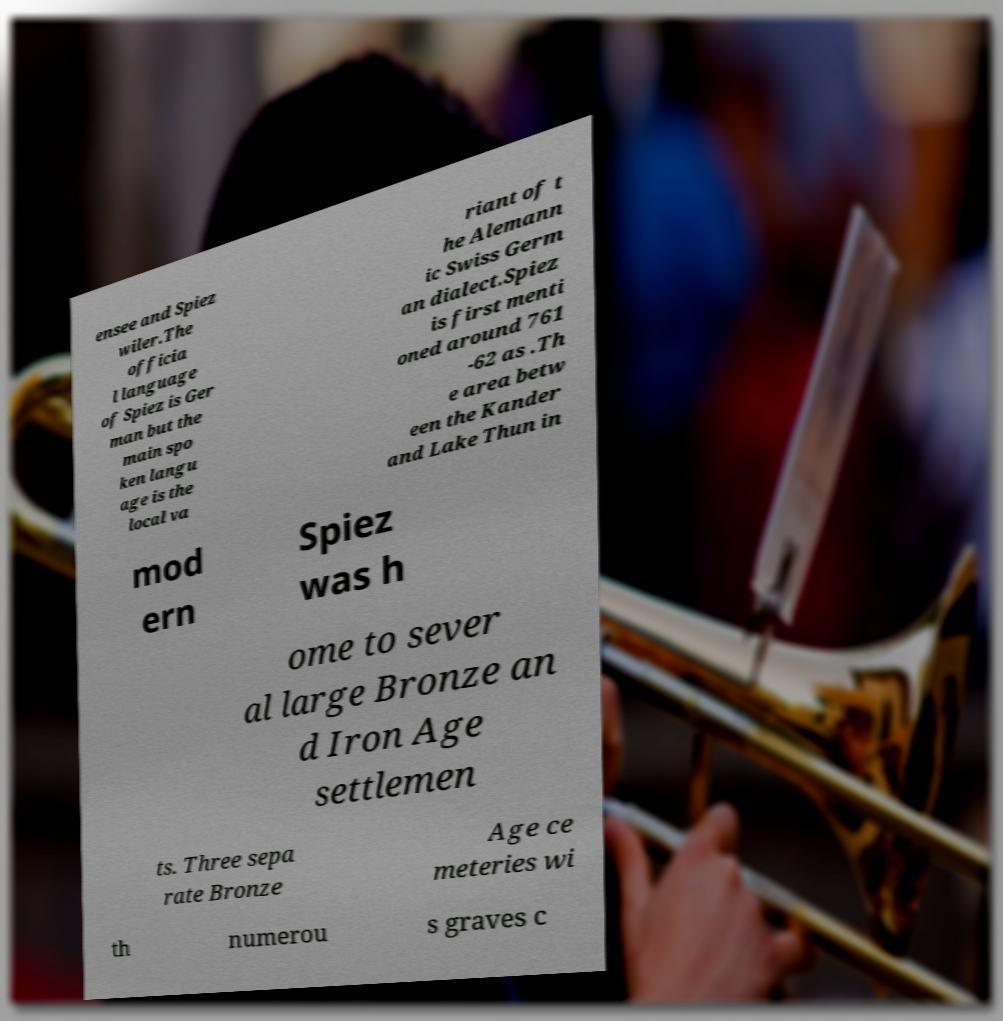Please read and relay the text visible in this image. What does it say? ensee and Spiez wiler.The officia l language of Spiez is Ger man but the main spo ken langu age is the local va riant of t he Alemann ic Swiss Germ an dialect.Spiez is first menti oned around 761 -62 as .Th e area betw een the Kander and Lake Thun in mod ern Spiez was h ome to sever al large Bronze an d Iron Age settlemen ts. Three sepa rate Bronze Age ce meteries wi th numerou s graves c 